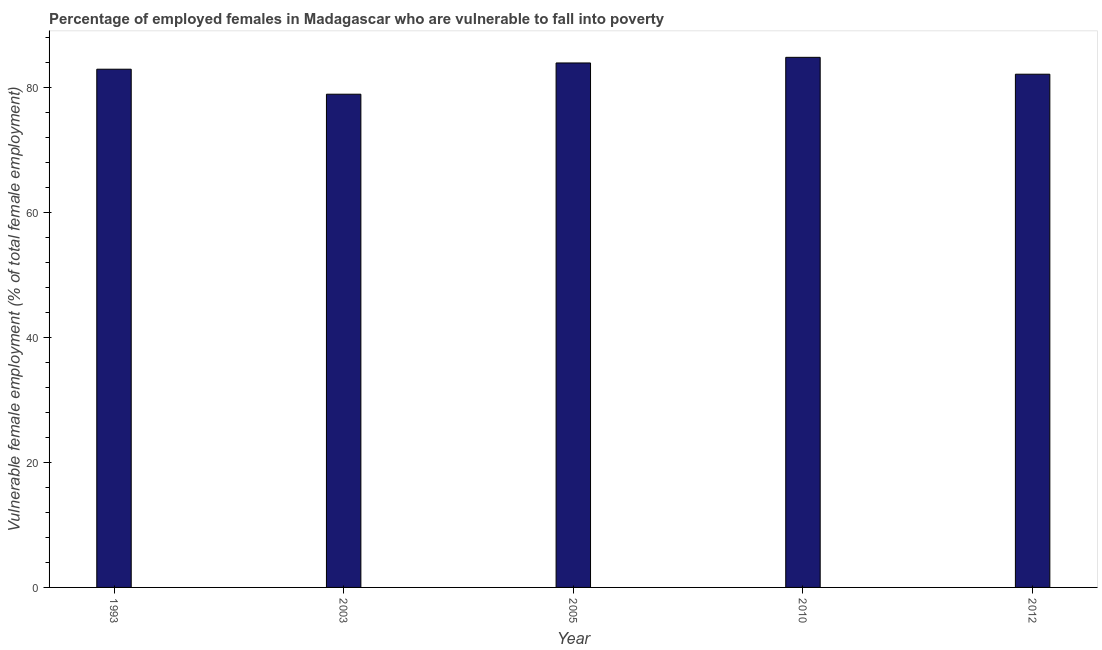What is the title of the graph?
Make the answer very short. Percentage of employed females in Madagascar who are vulnerable to fall into poverty. What is the label or title of the Y-axis?
Provide a succinct answer. Vulnerable female employment (% of total female employment). What is the percentage of employed females who are vulnerable to fall into poverty in 1993?
Your response must be concise. 82.9. Across all years, what is the maximum percentage of employed females who are vulnerable to fall into poverty?
Make the answer very short. 84.8. Across all years, what is the minimum percentage of employed females who are vulnerable to fall into poverty?
Ensure brevity in your answer.  78.9. In which year was the percentage of employed females who are vulnerable to fall into poverty minimum?
Keep it short and to the point. 2003. What is the sum of the percentage of employed females who are vulnerable to fall into poverty?
Ensure brevity in your answer.  412.6. What is the average percentage of employed females who are vulnerable to fall into poverty per year?
Offer a very short reply. 82.52. What is the median percentage of employed females who are vulnerable to fall into poverty?
Ensure brevity in your answer.  82.9. In how many years, is the percentage of employed females who are vulnerable to fall into poverty greater than 20 %?
Keep it short and to the point. 5. What is the ratio of the percentage of employed females who are vulnerable to fall into poverty in 2003 to that in 2010?
Provide a short and direct response. 0.93. Is the percentage of employed females who are vulnerable to fall into poverty in 1993 less than that in 2012?
Give a very brief answer. No. What is the difference between the highest and the second highest percentage of employed females who are vulnerable to fall into poverty?
Offer a terse response. 0.9. In how many years, is the percentage of employed females who are vulnerable to fall into poverty greater than the average percentage of employed females who are vulnerable to fall into poverty taken over all years?
Make the answer very short. 3. Are all the bars in the graph horizontal?
Ensure brevity in your answer.  No. Are the values on the major ticks of Y-axis written in scientific E-notation?
Offer a very short reply. No. What is the Vulnerable female employment (% of total female employment) of 1993?
Offer a very short reply. 82.9. What is the Vulnerable female employment (% of total female employment) of 2003?
Your answer should be very brief. 78.9. What is the Vulnerable female employment (% of total female employment) in 2005?
Provide a short and direct response. 83.9. What is the Vulnerable female employment (% of total female employment) of 2010?
Offer a terse response. 84.8. What is the Vulnerable female employment (% of total female employment) of 2012?
Your response must be concise. 82.1. What is the difference between the Vulnerable female employment (% of total female employment) in 1993 and 2003?
Your answer should be compact. 4. What is the difference between the Vulnerable female employment (% of total female employment) in 2003 and 2010?
Provide a succinct answer. -5.9. What is the difference between the Vulnerable female employment (% of total female employment) in 2003 and 2012?
Provide a short and direct response. -3.2. What is the difference between the Vulnerable female employment (% of total female employment) in 2005 and 2010?
Your answer should be very brief. -0.9. What is the difference between the Vulnerable female employment (% of total female employment) in 2005 and 2012?
Provide a succinct answer. 1.8. What is the difference between the Vulnerable female employment (% of total female employment) in 2010 and 2012?
Your answer should be compact. 2.7. What is the ratio of the Vulnerable female employment (% of total female employment) in 1993 to that in 2003?
Your answer should be compact. 1.05. What is the ratio of the Vulnerable female employment (% of total female employment) in 1993 to that in 2010?
Your answer should be very brief. 0.98. What is the ratio of the Vulnerable female employment (% of total female employment) in 2003 to that in 2005?
Provide a short and direct response. 0.94. What is the ratio of the Vulnerable female employment (% of total female employment) in 2003 to that in 2010?
Give a very brief answer. 0.93. What is the ratio of the Vulnerable female employment (% of total female employment) in 2003 to that in 2012?
Provide a succinct answer. 0.96. What is the ratio of the Vulnerable female employment (% of total female employment) in 2010 to that in 2012?
Make the answer very short. 1.03. 